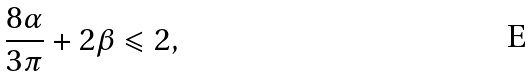<formula> <loc_0><loc_0><loc_500><loc_500>\frac { 8 \alpha } { 3 \pi } + 2 \beta \leqslant 2 ,</formula> 